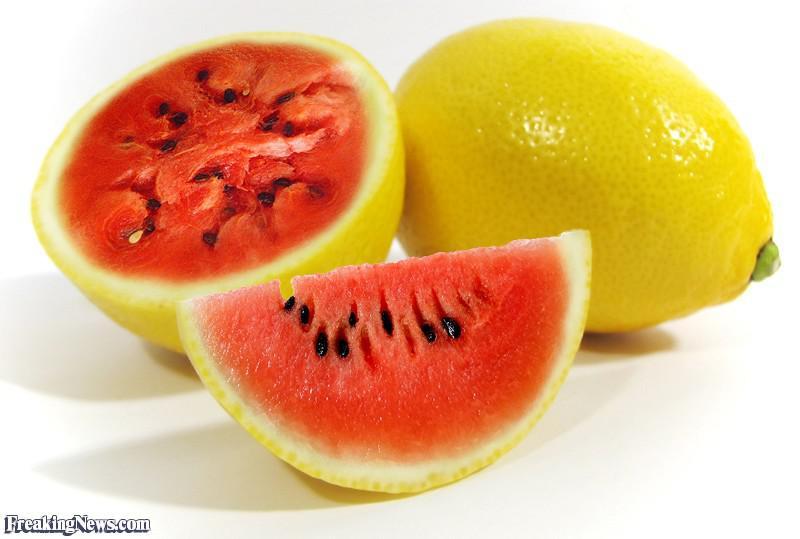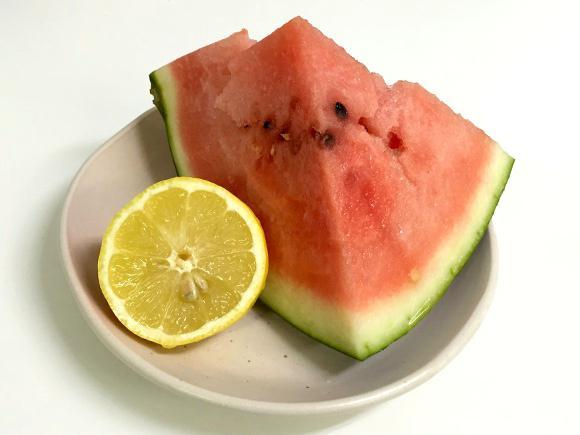The first image is the image on the left, the second image is the image on the right. Examine the images to the left and right. Is the description "At least one image features more than one whole lemon." accurate? Answer yes or no. No. 